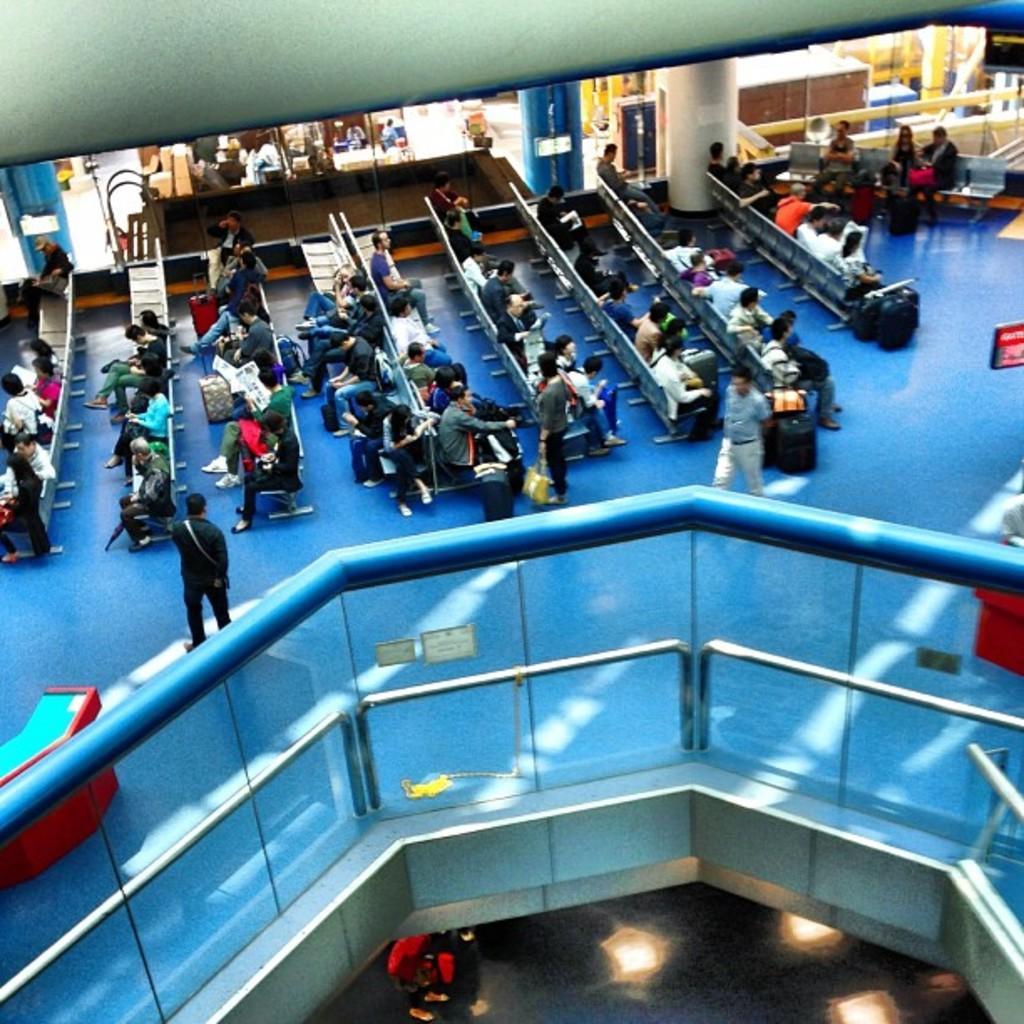Could you give a brief overview of what you see in this image? In this image we can see a few people, some of them are sitting on the chairs, a few of them are holding bags, there is a grill, windows, poles, posters, and a table. 